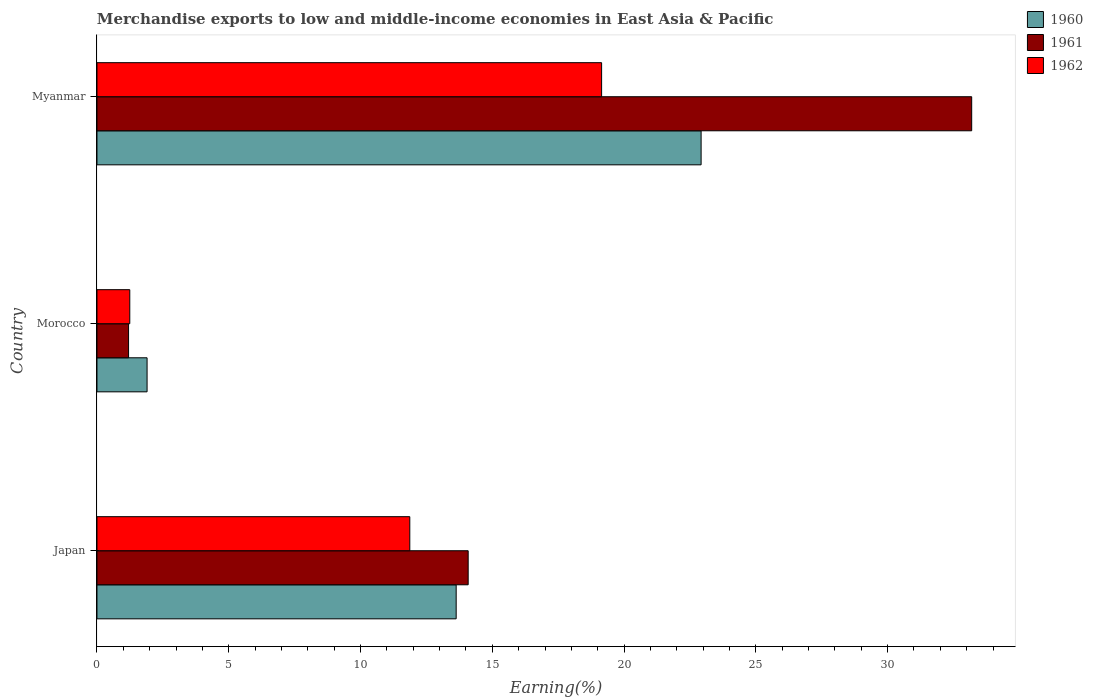How many different coloured bars are there?
Provide a succinct answer. 3. How many bars are there on the 3rd tick from the top?
Offer a terse response. 3. What is the label of the 1st group of bars from the top?
Offer a terse response. Myanmar. In how many cases, is the number of bars for a given country not equal to the number of legend labels?
Ensure brevity in your answer.  0. What is the percentage of amount earned from merchandise exports in 1961 in Morocco?
Offer a very short reply. 1.2. Across all countries, what is the maximum percentage of amount earned from merchandise exports in 1960?
Your answer should be very brief. 22.92. Across all countries, what is the minimum percentage of amount earned from merchandise exports in 1961?
Offer a very short reply. 1.2. In which country was the percentage of amount earned from merchandise exports in 1960 maximum?
Your response must be concise. Myanmar. In which country was the percentage of amount earned from merchandise exports in 1960 minimum?
Provide a succinct answer. Morocco. What is the total percentage of amount earned from merchandise exports in 1960 in the graph?
Give a very brief answer. 38.45. What is the difference between the percentage of amount earned from merchandise exports in 1961 in Japan and that in Myanmar?
Make the answer very short. -19.11. What is the difference between the percentage of amount earned from merchandise exports in 1962 in Myanmar and the percentage of amount earned from merchandise exports in 1960 in Morocco?
Your response must be concise. 17.25. What is the average percentage of amount earned from merchandise exports in 1960 per country?
Make the answer very short. 12.82. What is the difference between the percentage of amount earned from merchandise exports in 1961 and percentage of amount earned from merchandise exports in 1960 in Japan?
Make the answer very short. 0.46. In how many countries, is the percentage of amount earned from merchandise exports in 1960 greater than 20 %?
Give a very brief answer. 1. What is the ratio of the percentage of amount earned from merchandise exports in 1962 in Japan to that in Myanmar?
Keep it short and to the point. 0.62. Is the percentage of amount earned from merchandise exports in 1960 in Japan less than that in Morocco?
Give a very brief answer. No. Is the difference between the percentage of amount earned from merchandise exports in 1961 in Japan and Myanmar greater than the difference between the percentage of amount earned from merchandise exports in 1960 in Japan and Myanmar?
Keep it short and to the point. No. What is the difference between the highest and the second highest percentage of amount earned from merchandise exports in 1961?
Provide a short and direct response. 19.11. What is the difference between the highest and the lowest percentage of amount earned from merchandise exports in 1962?
Offer a very short reply. 17.9. What does the 1st bar from the bottom in Morocco represents?
Keep it short and to the point. 1960. Is it the case that in every country, the sum of the percentage of amount earned from merchandise exports in 1960 and percentage of amount earned from merchandise exports in 1962 is greater than the percentage of amount earned from merchandise exports in 1961?
Your answer should be compact. Yes. What is the difference between two consecutive major ticks on the X-axis?
Your response must be concise. 5. Are the values on the major ticks of X-axis written in scientific E-notation?
Provide a succinct answer. No. Does the graph contain any zero values?
Provide a succinct answer. No. How many legend labels are there?
Offer a terse response. 3. How are the legend labels stacked?
Provide a short and direct response. Vertical. What is the title of the graph?
Your response must be concise. Merchandise exports to low and middle-income economies in East Asia & Pacific. What is the label or title of the X-axis?
Your answer should be very brief. Earning(%). What is the Earning(%) in 1960 in Japan?
Keep it short and to the point. 13.63. What is the Earning(%) in 1961 in Japan?
Give a very brief answer. 14.09. What is the Earning(%) of 1962 in Japan?
Your response must be concise. 11.87. What is the Earning(%) in 1960 in Morocco?
Your response must be concise. 1.9. What is the Earning(%) in 1961 in Morocco?
Provide a succinct answer. 1.2. What is the Earning(%) in 1962 in Morocco?
Offer a very short reply. 1.25. What is the Earning(%) of 1960 in Myanmar?
Offer a terse response. 22.92. What is the Earning(%) of 1961 in Myanmar?
Keep it short and to the point. 33.19. What is the Earning(%) in 1962 in Myanmar?
Make the answer very short. 19.15. Across all countries, what is the maximum Earning(%) in 1960?
Provide a short and direct response. 22.92. Across all countries, what is the maximum Earning(%) of 1961?
Give a very brief answer. 33.19. Across all countries, what is the maximum Earning(%) in 1962?
Offer a very short reply. 19.15. Across all countries, what is the minimum Earning(%) of 1960?
Offer a terse response. 1.9. Across all countries, what is the minimum Earning(%) of 1961?
Your answer should be compact. 1.2. Across all countries, what is the minimum Earning(%) of 1962?
Your response must be concise. 1.25. What is the total Earning(%) in 1960 in the graph?
Ensure brevity in your answer.  38.45. What is the total Earning(%) in 1961 in the graph?
Keep it short and to the point. 48.48. What is the total Earning(%) of 1962 in the graph?
Make the answer very short. 32.26. What is the difference between the Earning(%) in 1960 in Japan and that in Morocco?
Provide a short and direct response. 11.73. What is the difference between the Earning(%) of 1961 in Japan and that in Morocco?
Provide a succinct answer. 12.89. What is the difference between the Earning(%) in 1962 in Japan and that in Morocco?
Your answer should be very brief. 10.62. What is the difference between the Earning(%) in 1960 in Japan and that in Myanmar?
Offer a very short reply. -9.29. What is the difference between the Earning(%) in 1961 in Japan and that in Myanmar?
Provide a succinct answer. -19.11. What is the difference between the Earning(%) in 1962 in Japan and that in Myanmar?
Make the answer very short. -7.28. What is the difference between the Earning(%) of 1960 in Morocco and that in Myanmar?
Give a very brief answer. -21.02. What is the difference between the Earning(%) in 1961 in Morocco and that in Myanmar?
Keep it short and to the point. -31.99. What is the difference between the Earning(%) of 1962 in Morocco and that in Myanmar?
Your response must be concise. -17.9. What is the difference between the Earning(%) in 1960 in Japan and the Earning(%) in 1961 in Morocco?
Make the answer very short. 12.43. What is the difference between the Earning(%) in 1960 in Japan and the Earning(%) in 1962 in Morocco?
Keep it short and to the point. 12.38. What is the difference between the Earning(%) of 1961 in Japan and the Earning(%) of 1962 in Morocco?
Your answer should be very brief. 12.84. What is the difference between the Earning(%) of 1960 in Japan and the Earning(%) of 1961 in Myanmar?
Your response must be concise. -19.56. What is the difference between the Earning(%) in 1960 in Japan and the Earning(%) in 1962 in Myanmar?
Offer a terse response. -5.52. What is the difference between the Earning(%) in 1961 in Japan and the Earning(%) in 1962 in Myanmar?
Offer a very short reply. -5.06. What is the difference between the Earning(%) of 1960 in Morocco and the Earning(%) of 1961 in Myanmar?
Keep it short and to the point. -31.29. What is the difference between the Earning(%) of 1960 in Morocco and the Earning(%) of 1962 in Myanmar?
Ensure brevity in your answer.  -17.25. What is the difference between the Earning(%) of 1961 in Morocco and the Earning(%) of 1962 in Myanmar?
Keep it short and to the point. -17.95. What is the average Earning(%) of 1960 per country?
Make the answer very short. 12.82. What is the average Earning(%) in 1961 per country?
Keep it short and to the point. 16.16. What is the average Earning(%) in 1962 per country?
Offer a terse response. 10.75. What is the difference between the Earning(%) of 1960 and Earning(%) of 1961 in Japan?
Your answer should be very brief. -0.46. What is the difference between the Earning(%) in 1960 and Earning(%) in 1962 in Japan?
Make the answer very short. 1.76. What is the difference between the Earning(%) of 1961 and Earning(%) of 1962 in Japan?
Your answer should be compact. 2.22. What is the difference between the Earning(%) in 1960 and Earning(%) in 1961 in Morocco?
Offer a very short reply. 0.7. What is the difference between the Earning(%) of 1960 and Earning(%) of 1962 in Morocco?
Provide a succinct answer. 0.66. What is the difference between the Earning(%) of 1961 and Earning(%) of 1962 in Morocco?
Your response must be concise. -0.05. What is the difference between the Earning(%) in 1960 and Earning(%) in 1961 in Myanmar?
Ensure brevity in your answer.  -10.27. What is the difference between the Earning(%) of 1960 and Earning(%) of 1962 in Myanmar?
Your answer should be compact. 3.78. What is the difference between the Earning(%) of 1961 and Earning(%) of 1962 in Myanmar?
Offer a very short reply. 14.04. What is the ratio of the Earning(%) in 1960 in Japan to that in Morocco?
Your response must be concise. 7.17. What is the ratio of the Earning(%) in 1961 in Japan to that in Morocco?
Keep it short and to the point. 11.75. What is the ratio of the Earning(%) of 1962 in Japan to that in Morocco?
Provide a short and direct response. 9.53. What is the ratio of the Earning(%) of 1960 in Japan to that in Myanmar?
Your answer should be very brief. 0.59. What is the ratio of the Earning(%) in 1961 in Japan to that in Myanmar?
Your answer should be compact. 0.42. What is the ratio of the Earning(%) of 1962 in Japan to that in Myanmar?
Your answer should be very brief. 0.62. What is the ratio of the Earning(%) of 1960 in Morocco to that in Myanmar?
Offer a terse response. 0.08. What is the ratio of the Earning(%) of 1961 in Morocco to that in Myanmar?
Your response must be concise. 0.04. What is the ratio of the Earning(%) of 1962 in Morocco to that in Myanmar?
Provide a short and direct response. 0.07. What is the difference between the highest and the second highest Earning(%) in 1960?
Your response must be concise. 9.29. What is the difference between the highest and the second highest Earning(%) in 1961?
Offer a very short reply. 19.11. What is the difference between the highest and the second highest Earning(%) of 1962?
Your answer should be compact. 7.28. What is the difference between the highest and the lowest Earning(%) in 1960?
Offer a terse response. 21.02. What is the difference between the highest and the lowest Earning(%) in 1961?
Ensure brevity in your answer.  31.99. What is the difference between the highest and the lowest Earning(%) of 1962?
Your answer should be very brief. 17.9. 